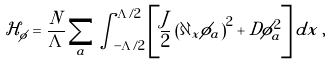Convert formula to latex. <formula><loc_0><loc_0><loc_500><loc_500>\mathcal { H } _ { \phi } = \frac { N } { \Lambda } \sum _ { a } \int _ { - \Lambda / 2 } ^ { \Lambda / 2 } \left [ \frac { J } { 2 } \left ( \partial _ { x } \phi _ { a } \right ) ^ { 2 } + D \phi _ { a } ^ { 2 } \right ] d x \, ,</formula> 